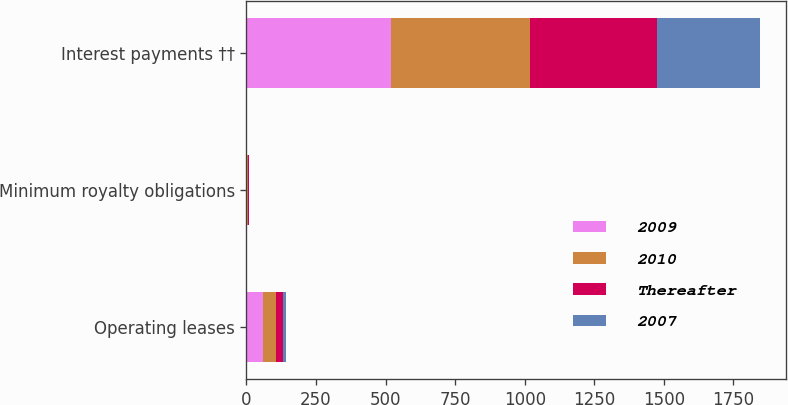Convert chart to OTSL. <chart><loc_0><loc_0><loc_500><loc_500><stacked_bar_chart><ecel><fcel>Operating leases<fcel>Minimum royalty obligations<fcel>Interest payments ††<nl><fcel>2009<fcel>61<fcel>3<fcel>521<nl><fcel>2010<fcel>47<fcel>3<fcel>497<nl><fcel>Thereafter<fcel>24<fcel>3<fcel>457<nl><fcel>2007<fcel>11<fcel>1<fcel>371<nl></chart> 